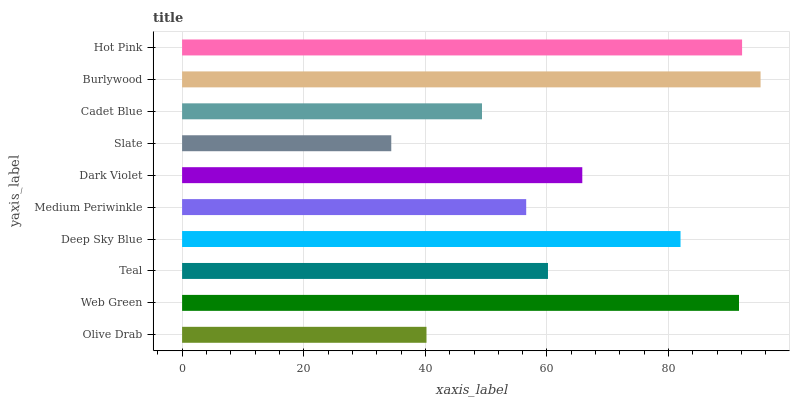Is Slate the minimum?
Answer yes or no. Yes. Is Burlywood the maximum?
Answer yes or no. Yes. Is Web Green the minimum?
Answer yes or no. No. Is Web Green the maximum?
Answer yes or no. No. Is Web Green greater than Olive Drab?
Answer yes or no. Yes. Is Olive Drab less than Web Green?
Answer yes or no. Yes. Is Olive Drab greater than Web Green?
Answer yes or no. No. Is Web Green less than Olive Drab?
Answer yes or no. No. Is Dark Violet the high median?
Answer yes or no. Yes. Is Teal the low median?
Answer yes or no. Yes. Is Cadet Blue the high median?
Answer yes or no. No. Is Dark Violet the low median?
Answer yes or no. No. 